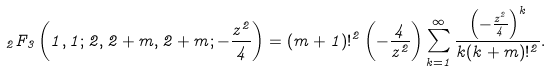<formula> <loc_0><loc_0><loc_500><loc_500>_ { 2 } F _ { 3 } \left ( 1 , 1 ; 2 , 2 + m , 2 + m ; - \frac { z ^ { 2 } } { 4 } \right ) = ( m + 1 ) ! ^ { 2 } \left ( - \frac { 4 } { z ^ { 2 } } \right ) \sum _ { k = 1 } ^ { \infty } \frac { \left ( - \frac { z ^ { 2 } } { 4 } \right ) ^ { k } } { k ( k + m ) ! ^ { 2 } } .</formula> 